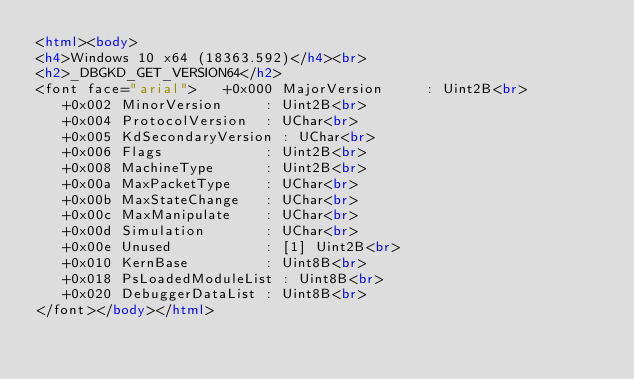<code> <loc_0><loc_0><loc_500><loc_500><_HTML_><html><body>
<h4>Windows 10 x64 (18363.592)</h4><br>
<h2>_DBGKD_GET_VERSION64</h2>
<font face="arial">   +0x000 MajorVersion     : Uint2B<br>
   +0x002 MinorVersion     : Uint2B<br>
   +0x004 ProtocolVersion  : UChar<br>
   +0x005 KdSecondaryVersion : UChar<br>
   +0x006 Flags            : Uint2B<br>
   +0x008 MachineType      : Uint2B<br>
   +0x00a MaxPacketType    : UChar<br>
   +0x00b MaxStateChange   : UChar<br>
   +0x00c MaxManipulate    : UChar<br>
   +0x00d Simulation       : UChar<br>
   +0x00e Unused           : [1] Uint2B<br>
   +0x010 KernBase         : Uint8B<br>
   +0x018 PsLoadedModuleList : Uint8B<br>
   +0x020 DebuggerDataList : Uint8B<br>
</font></body></html></code> 